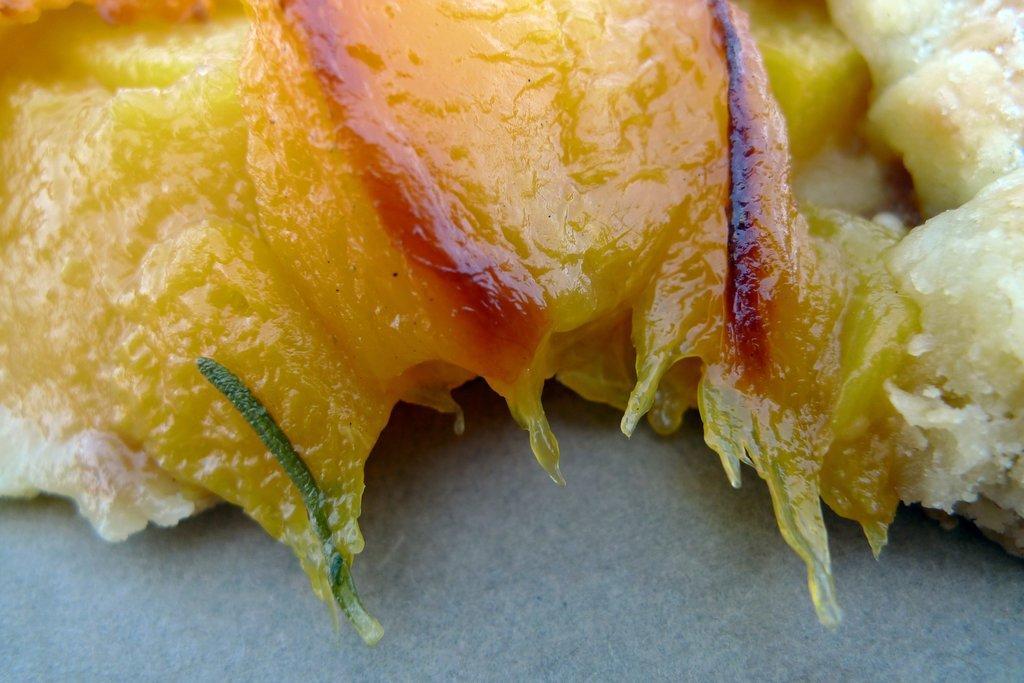Please provide a concise description of this image. In this image we can see food item on a surface. 